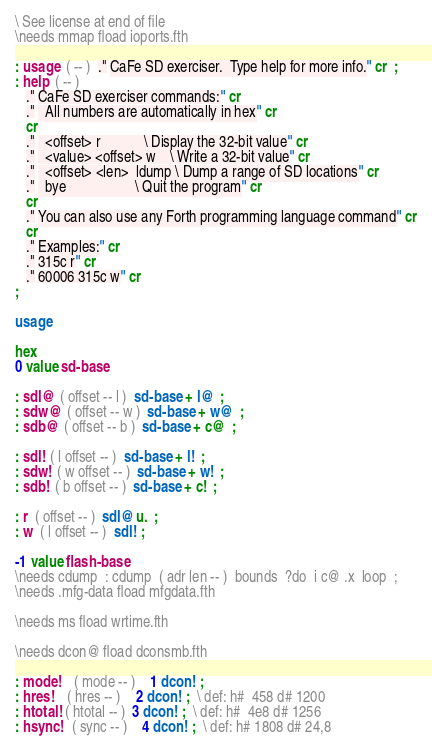<code> <loc_0><loc_0><loc_500><loc_500><_Forth_>\ See license at end of file
\needs mmap fload ioports.fth

: usage  ( -- )  ." CaFe SD exerciser.  Type help for more info." cr  ;
: help  ( -- )
   ." CaFe SD exerciser commands:" cr
   ."   All numbers are automatically in hex" cr
   cr
   ."   <offset> r            \ Display the 32-bit value" cr
   ."   <value> <offset> w    \ Write a 32-bit value" cr
   ."   <offset> <len>  ldump \ Dump a range of SD locations" cr
   ."   bye                   \ Quit the program" cr
   cr
   ." You can also use any Forth programming language command" cr
   cr
   ." Examples:" cr
   ." 315c r" cr
   ." 60006 315c w" cr
;

usage

hex
0 value sd-base

: sdl@  ( offset -- l )  sd-base + l@  ;
: sdw@  ( offset -- w )  sd-base + w@  ;
: sdb@  ( offset -- b )  sd-base + c@  ;

: sdl!  ( l offset -- )  sd-base + l!  ;
: sdw!  ( w offset -- )  sd-base + w!  ;
: sdb!  ( b offset -- )  sd-base + c!  ;

: r  ( offset -- )  sdl@ u.  ;
: w  ( l offset -- )  sdl!  ;

-1 value flash-base
\needs cdump  : cdump  ( adr len -- )  bounds  ?do  i c@ .x  loop  ;
\needs .mfg-data fload mfgdata.fth

\needs ms fload wrtime.fth

\needs dcon@ fload dconsmb.fth

: mode!    ( mode -- )    1 dcon!  ;
: hres!    ( hres -- )    2 dcon!  ;  \ def: h#  458 d# 1200
: htotal!  ( htotal -- )  3 dcon!  ;  \ def: h#  4e8 d# 1256
: hsync!   ( sync -- )    4 dcon!  ;  \ def: h# 1808 d# 24,8</code> 